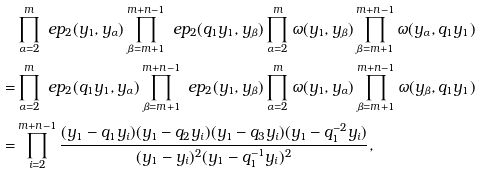Convert formula to latex. <formula><loc_0><loc_0><loc_500><loc_500>& \prod _ { \alpha = 2 } ^ { m } \ e p _ { 2 } ( y _ { 1 } , y _ { \alpha } ) \prod _ { \beta = m + 1 } ^ { m + n - 1 } \ e p _ { 2 } ( q _ { 1 } y _ { 1 } , y _ { \beta } ) \prod _ { \alpha = 2 } ^ { m } \omega ( y _ { 1 } , y _ { \beta } ) \prod _ { \beta = m + 1 } ^ { m + n - 1 } \omega ( y _ { \alpha } , q _ { 1 } y _ { 1 } ) \\ = & \prod _ { \alpha = 2 } ^ { m } \ e p _ { 2 } ( q _ { 1 } y _ { 1 } , y _ { \alpha } ) \prod _ { \beta = m + 1 } ^ { m + n - 1 } \ e p _ { 2 } ( y _ { 1 } , y _ { \beta } ) \prod _ { \alpha = 2 } ^ { m } \omega ( y _ { 1 } , y _ { \alpha } ) \prod _ { \beta = m + 1 } ^ { m + n - 1 } \omega ( y _ { \beta } , q _ { 1 } y _ { 1 } ) \\ = & \prod _ { i = 2 } ^ { m + n - 1 } \frac { ( y _ { 1 } - q _ { 1 } y _ { i } ) ( y _ { 1 } - q _ { 2 } y _ { i } ) ( y _ { 1 } - q _ { 3 } y _ { i } ) ( y _ { 1 } - q _ { 1 } ^ { - 2 } y _ { i } ) } { ( y _ { 1 } - y _ { i } ) ^ { 2 } ( y _ { 1 } - q _ { 1 } ^ { - 1 } y _ { i } ) ^ { 2 } } ,</formula> 